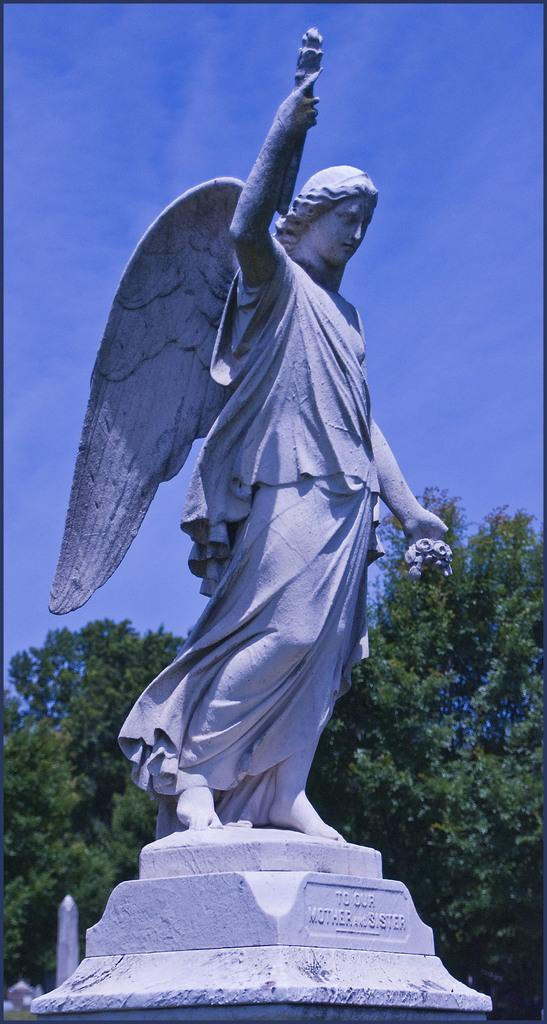What is the main subject of the picture? The main subject of the picture is a statue. Can you describe the statue's position? The statue is standing. What feature does the statue have? The statue has wings. What can be seen in the background of the picture? There are trees in the backdrop of the picture. How would you describe the sky in the image? The sky is clear in the image. Can you tell me how many squirrels are sitting on top of the statue in the image? There are no squirrels present in the image, and therefore no such activity can be observed. What type of land can be seen surrounding the statue in the image? The image does not provide information about the type of land surrounding the statue. 